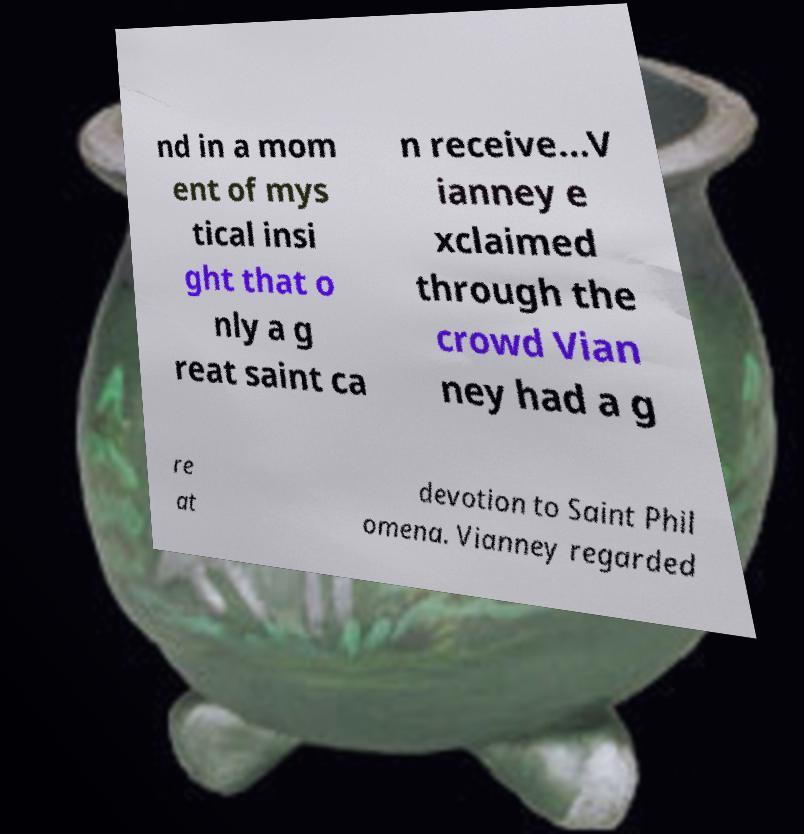For documentation purposes, I need the text within this image transcribed. Could you provide that? nd in a mom ent of mys tical insi ght that o nly a g reat saint ca n receive...V ianney e xclaimed through the crowd Vian ney had a g re at devotion to Saint Phil omena. Vianney regarded 